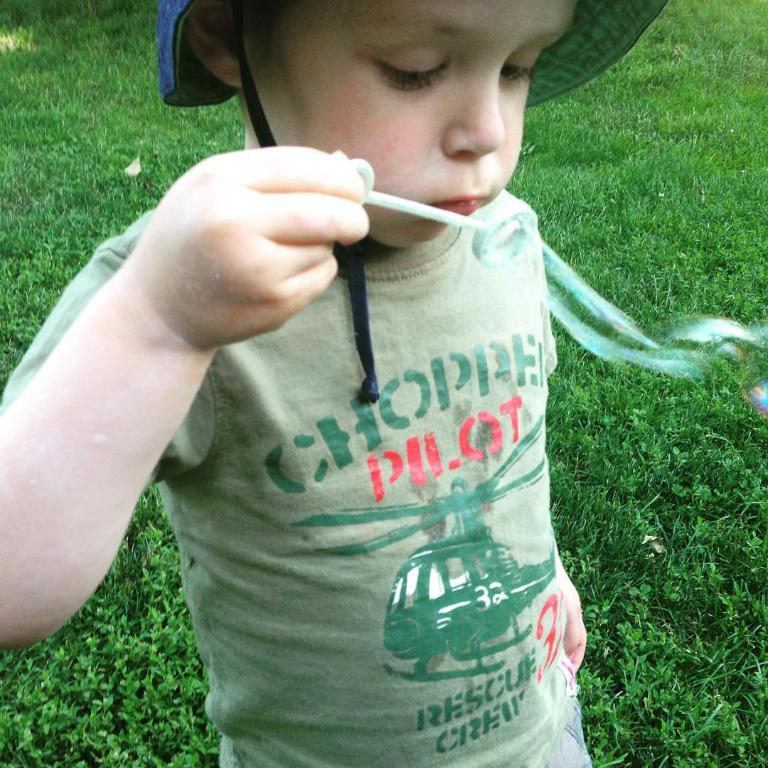What is the main subject of the image? There is a child in the image. What is the child wearing on their head? The child is wearing a hat. What is the child holding in their hand? The child is holding something in their hand. What activity is the child engaged in? The child is blowing bubbles. What type of environment is visible in the background of the image? There is grass visible in the background of the image. What is the acoustics of the child's laughter like in the image? There is no sound present in the image, so it is not possible to determine the acoustics of the child's laughter. 